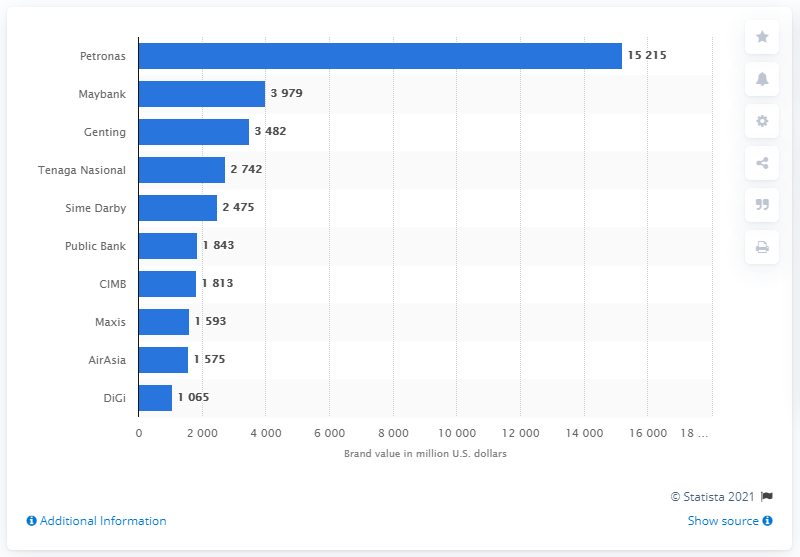Which sectors do the top Malaysian brands represent? The top Malaysian brands represent a variety of sectors. From the image, Petronas is in the oil and gas sector, Maybank and Public Bank are in banking, Genting is in hospitality, and Tenaga Nasional is in utilities. Other notable sectors include telecommunications with brands like Maxis and automotive with Sime Darby. 